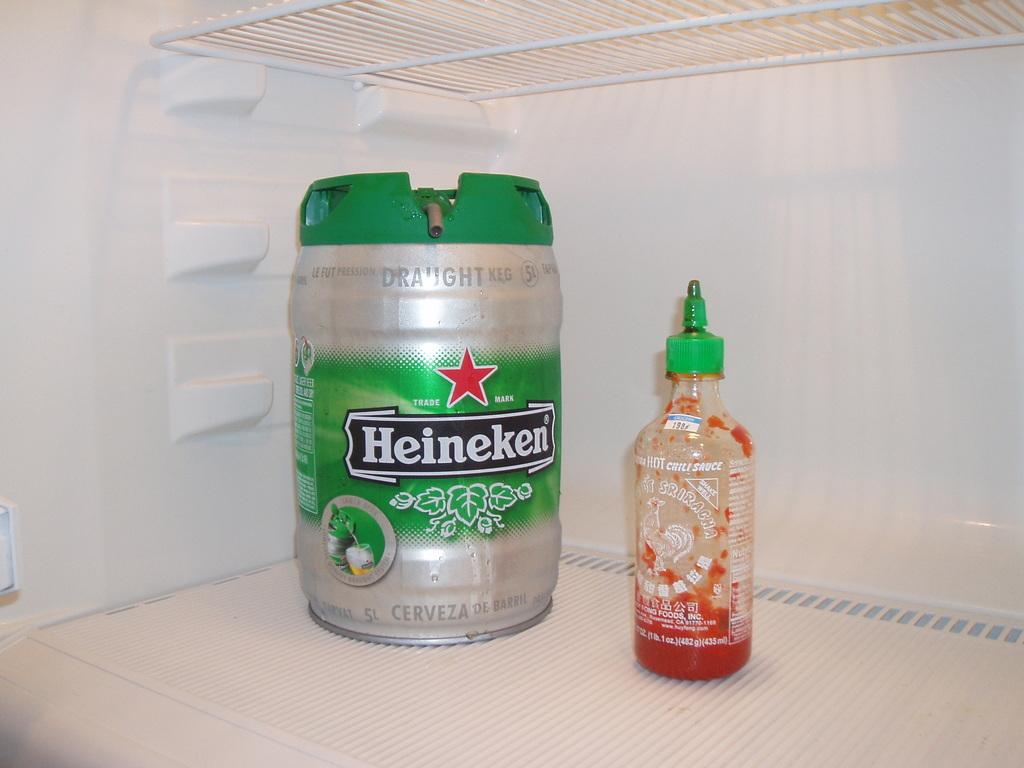<image>
Write a terse but informative summary of the picture. A can of Heineken is in the fridge next to a bottle of chili sauce. 